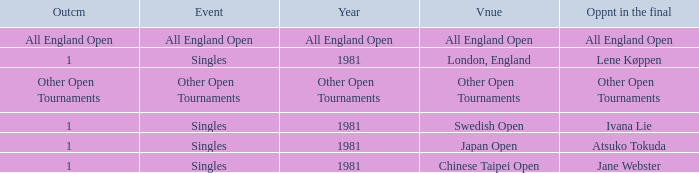What is the Outcome when All England Open is the Opponent in the final? All England Open. 